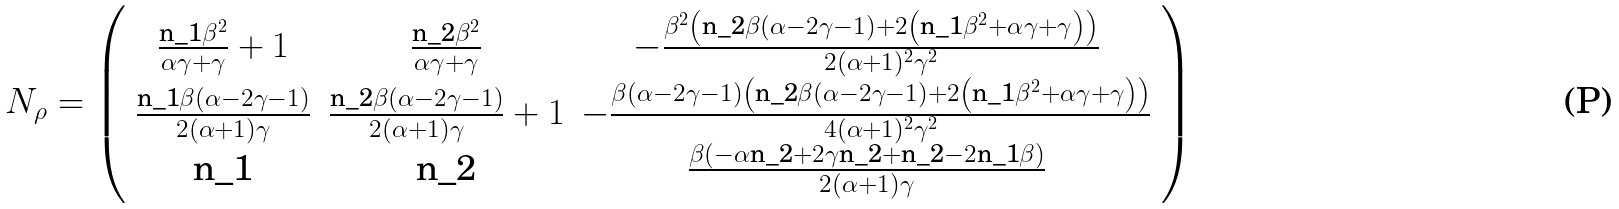<formula> <loc_0><loc_0><loc_500><loc_500>N _ { \rho } = \left ( \begin{array} { c c c } \frac { \text {n_{1}} \beta ^ { 2 } } { \alpha \gamma + \gamma } + 1 & \frac { \text {n_{2}} \beta ^ { 2 } } { \alpha \gamma + \gamma } & - \frac { \beta ^ { 2 } \left ( \text {n_{2}} \beta ( \alpha - 2 \gamma - 1 ) + 2 \left ( \text {n_{1}} \beta ^ { 2 } + \alpha \gamma + \gamma \right ) \right ) } { 2 ( \alpha + 1 ) ^ { 2 } \gamma ^ { 2 } } \\ \frac { \text {n_{1}} \beta ( \alpha - 2 \gamma - 1 ) } { 2 ( \alpha + 1 ) \gamma } & \frac { \text {n_{2}} \beta ( \alpha - 2 \gamma - 1 ) } { 2 ( \alpha + 1 ) \gamma } + 1 & - \frac { \beta ( \alpha - 2 \gamma - 1 ) \left ( \text {n_{2}} \beta ( \alpha - 2 \gamma - 1 ) + 2 \left ( \text {n_{1}} \beta ^ { 2 } + \alpha \gamma + \gamma \right ) \right ) } { 4 ( \alpha + 1 ) ^ { 2 } \gamma ^ { 2 } } \\ \text {n_{1}} & \text {n_{2}} & \frac { \beta ( - \alpha \text {n_{2}} + 2 \gamma \text {n_{2}} + \text {n_{2}} - 2 \text {n_{1}} \beta ) } { 2 ( \alpha + 1 ) \gamma } \end{array} \right )</formula> 